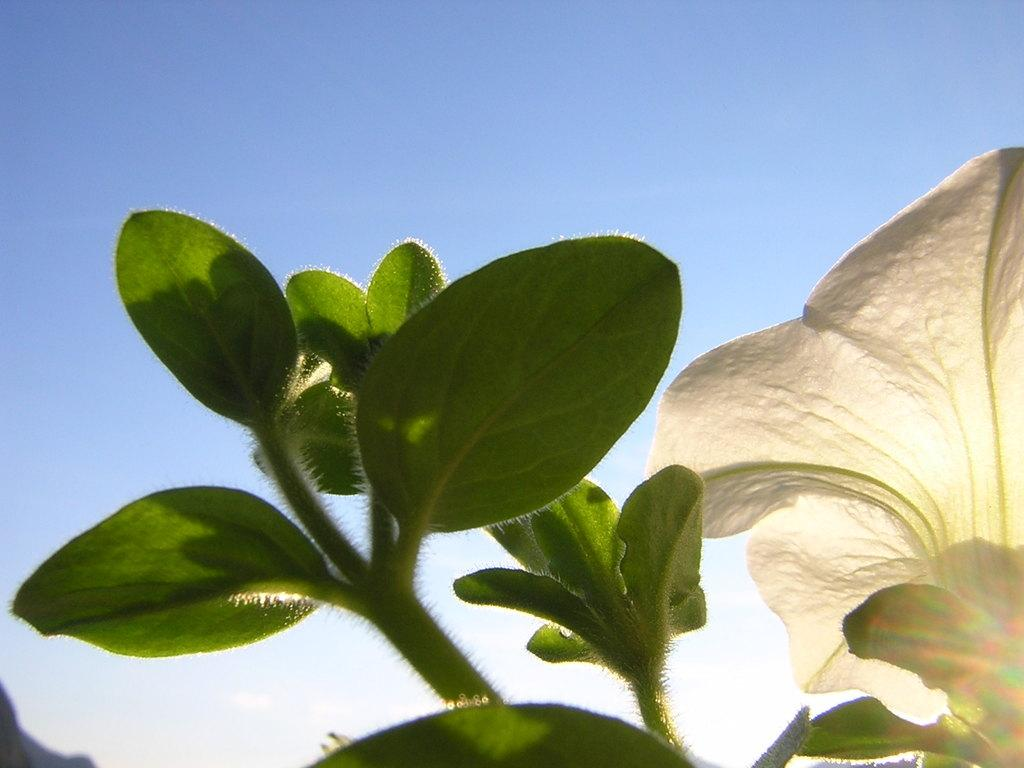What is the main subject of the picture? The main subject of the picture is a flower. Can you describe the color of the flower? The flower is white. Is the flower part of a larger plant? Yes, the flower is attached to a plant. What else can be seen on the flower besides the petals? The flower has leaves. What is the condition of the sky in the picture? The sky is clear in the picture. Can you tell me how many beetles are crawling on the flower in the picture? There are no beetles present on the flower in the image. What type of shame is depicted in the picture? There is no shame depicted in the picture; it features a white flower with leaves. 